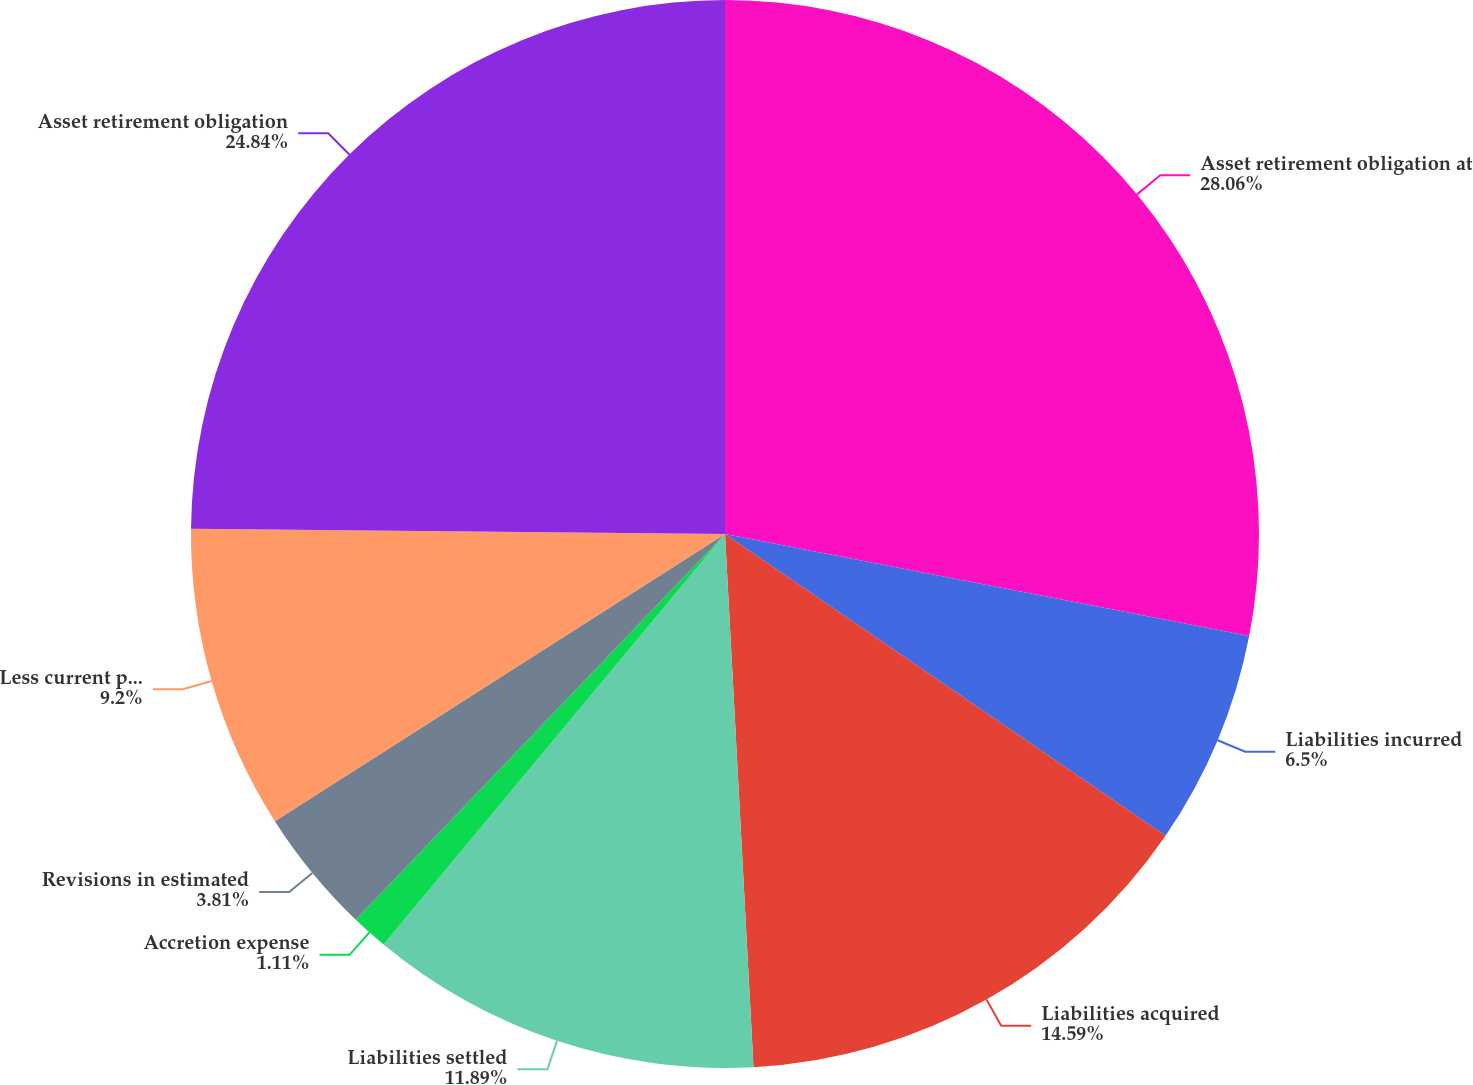Convert chart. <chart><loc_0><loc_0><loc_500><loc_500><pie_chart><fcel>Asset retirement obligation at<fcel>Liabilities incurred<fcel>Liabilities acquired<fcel>Liabilities settled<fcel>Accretion expense<fcel>Revisions in estimated<fcel>Less current portion<fcel>Asset retirement obligation<nl><fcel>28.06%<fcel>6.5%<fcel>14.59%<fcel>11.89%<fcel>1.11%<fcel>3.81%<fcel>9.2%<fcel>24.84%<nl></chart> 